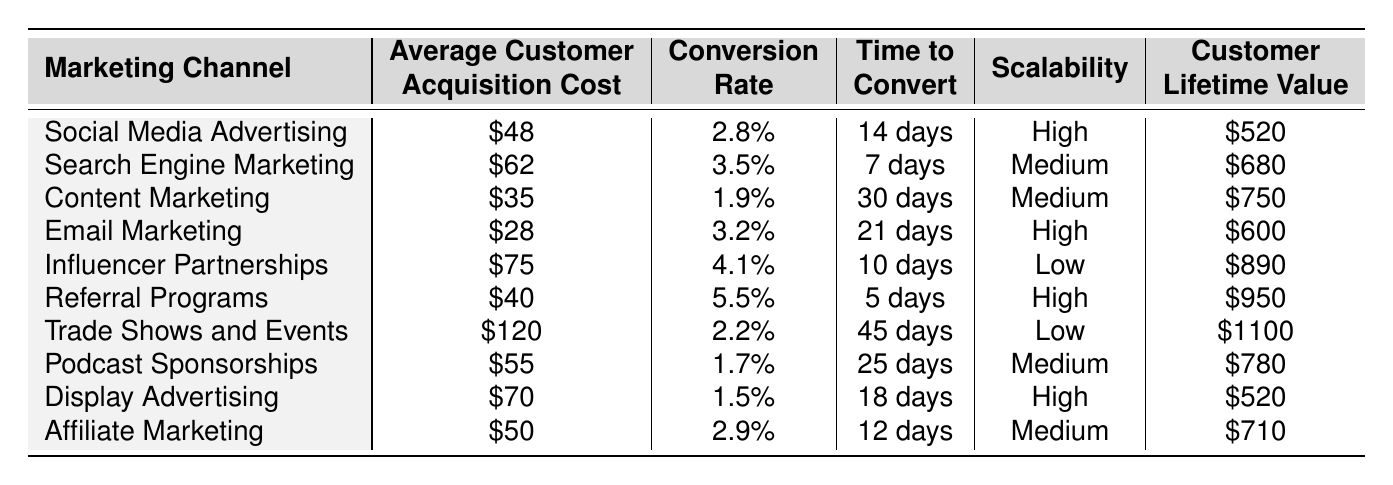What is the average customer acquisition cost for Email Marketing? The table lists Email Marketing with an average customer acquisition cost of $28.
Answer: $28 Which marketing channel has the highest conversion rate? Evaluating the conversion rates, Referral Programs at 5.5% has the highest value when compared to the other channels.
Answer: Referral Programs What is the time to convert for Search Engine Marketing? According to the table, the time to convert for Search Engine Marketing is 7 days.
Answer: 7 days Is the customer lifetime value for Influencer Partnerships higher than that for Email Marketing? The customer lifetime value for Influencer Partnerships is $890, while for Email Marketing it is $600. Since $890 is greater than $600, the statement is true.
Answer: Yes What is the difference in customer acquisition costs between Trade Shows and Events and Content Marketing? The table shows Trade Shows and Events at $120 and Content Marketing at $35. The difference is calculated as $120 - $35 = $85.
Answer: $85 Which marketing channel offers the best combination of cost-effectiveness (low acquisition cost) and high conversion rate? Analyzing the table shows Email Marketing has an average cost of $28 and a conversion rate of 3.2%, while Content Marketing has $35 and 1.9%. This indicates Email Marketing demonstrates the best combination of low cost and relatively high conversion rate.
Answer: Email Marketing Which marketing channel has the lowest customer lifetime value? By reviewing the customer lifetime values listed, Display Advertising has the lowest at $520, compared to the others.
Answer: Display Advertising If we average the customer acquisition costs of Social Media Advertising, Email Marketing, and Referral Programs, what do we get? The costs are $48 (Social Media) + $28 (Email) + $40 (Referral) = $116. Dividing by 3 gives an average of $116 / 3 = $38.67.
Answer: $38.67 Which marketing channel is the least scalable? The table indicates that Influencer Partnerships and Trade Shows and Events both have "Low" scalability, but Trade Shows and Events has the added factor of a high customer acquisition cost.
Answer: Influencer Partnerships Calculate the average conversion rate for all marketing channels. Adding all conversion rates gives: 2.8% + 3.5% + 1.9% + 3.2% + 4.1% + 5.5% + 2.2% + 1.7% + 1.5% + 2.9% = 25.9%. Dividing by 10 results in an average conversion rate of 2.59%.
Answer: 2.59% 